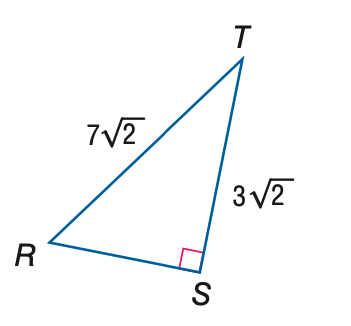Question: Find the measure of \angle T to the nearest tenth.
Choices:
A. 23.2
B. 25.4
C. 64.6
D. 66.8
Answer with the letter. Answer: C 